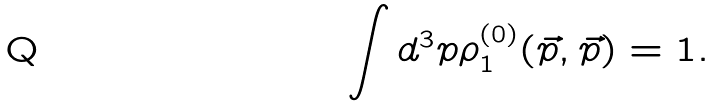<formula> <loc_0><loc_0><loc_500><loc_500>\int d ^ { 3 } p \rho _ { 1 } ^ { ( 0 ) } ( \vec { p } , \vec { p } ) = 1 .</formula> 